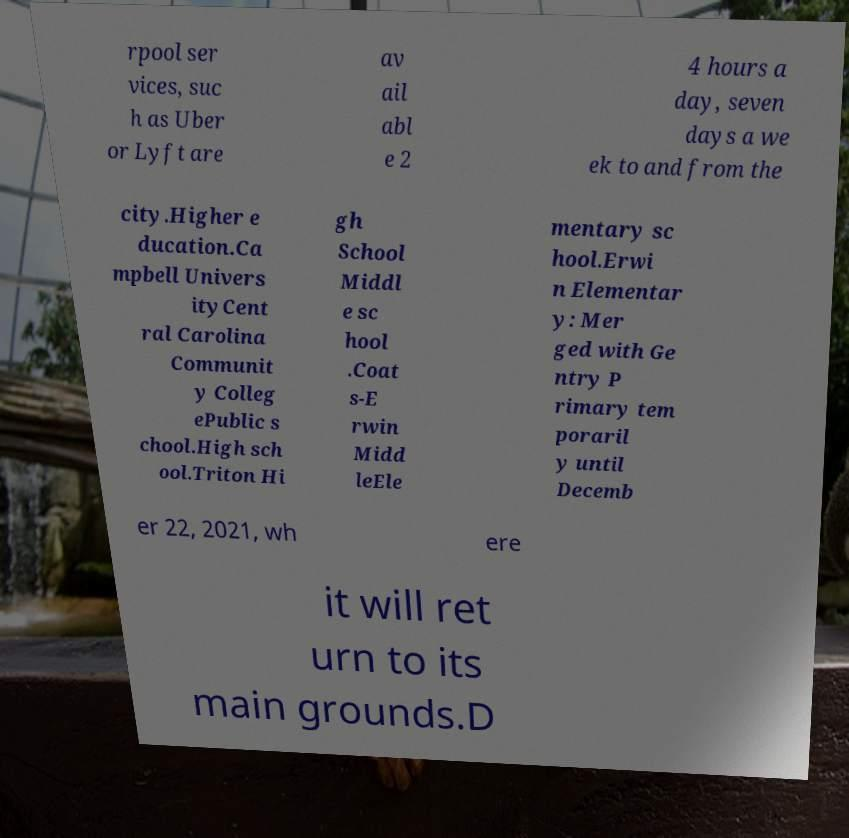Could you assist in decoding the text presented in this image and type it out clearly? rpool ser vices, suc h as Uber or Lyft are av ail abl e 2 4 hours a day, seven days a we ek to and from the city.Higher e ducation.Ca mpbell Univers ityCent ral Carolina Communit y Colleg ePublic s chool.High sch ool.Triton Hi gh School Middl e sc hool .Coat s-E rwin Midd leEle mentary sc hool.Erwi n Elementar y: Mer ged with Ge ntry P rimary tem poraril y until Decemb er 22, 2021, wh ere it will ret urn to its main grounds.D 